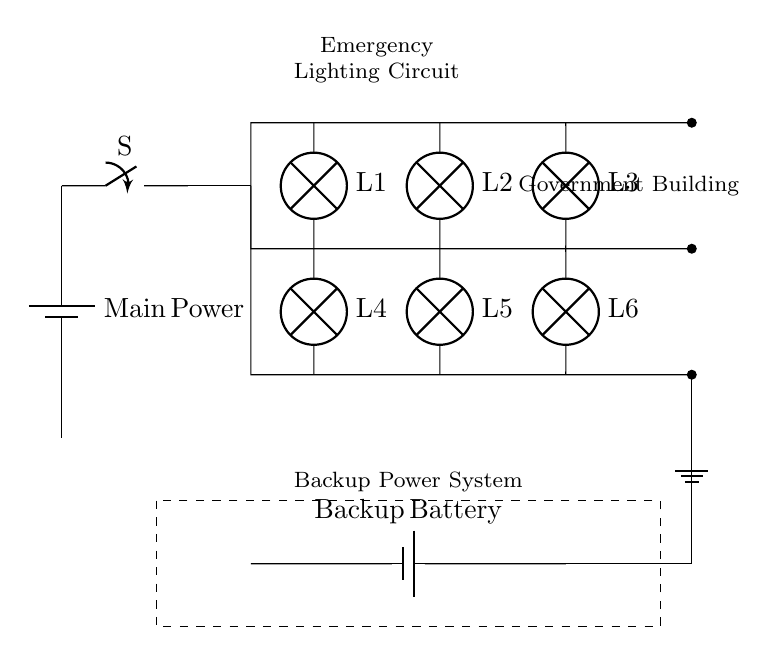What is the main power source? The main power source in the circuit is a battery labeled as "Main Power." It is located at the top of the circuit diagram providing power to the components below it.
Answer: Main Power How many emergency lights are connected in the circuit? The circuit diagram shows a total of six emergency lights labeled from L1 to L6. They are arranged in parallel, connected to the main distribution line.
Answer: Six What type of circuit is used for the emergency lighting system? The circuit is a parallel circuit, which is evident from the multiple branches connecting various lights to the same voltage source, allowing them to operate independently.
Answer: Parallel What component provides backup power during outages? The backup power source is a battery labeled as "Backup Battery." It is shown in the dashed rectangle representing the backup system that activates when main power fails.
Answer: Backup Battery What is the purpose of the switch shown in the circuit? The switch is used to control the flow of electricity from the main power supply to the emergency lights, allowing for manual control of the lights during power outages.
Answer: Control flow How many paths are available for current flow in the circuit? The circuit has six paths for current flow, each corresponding to one of the six emergency lights connected in parallel, allowing each to receive power simultaneously if needed.
Answer: Six 